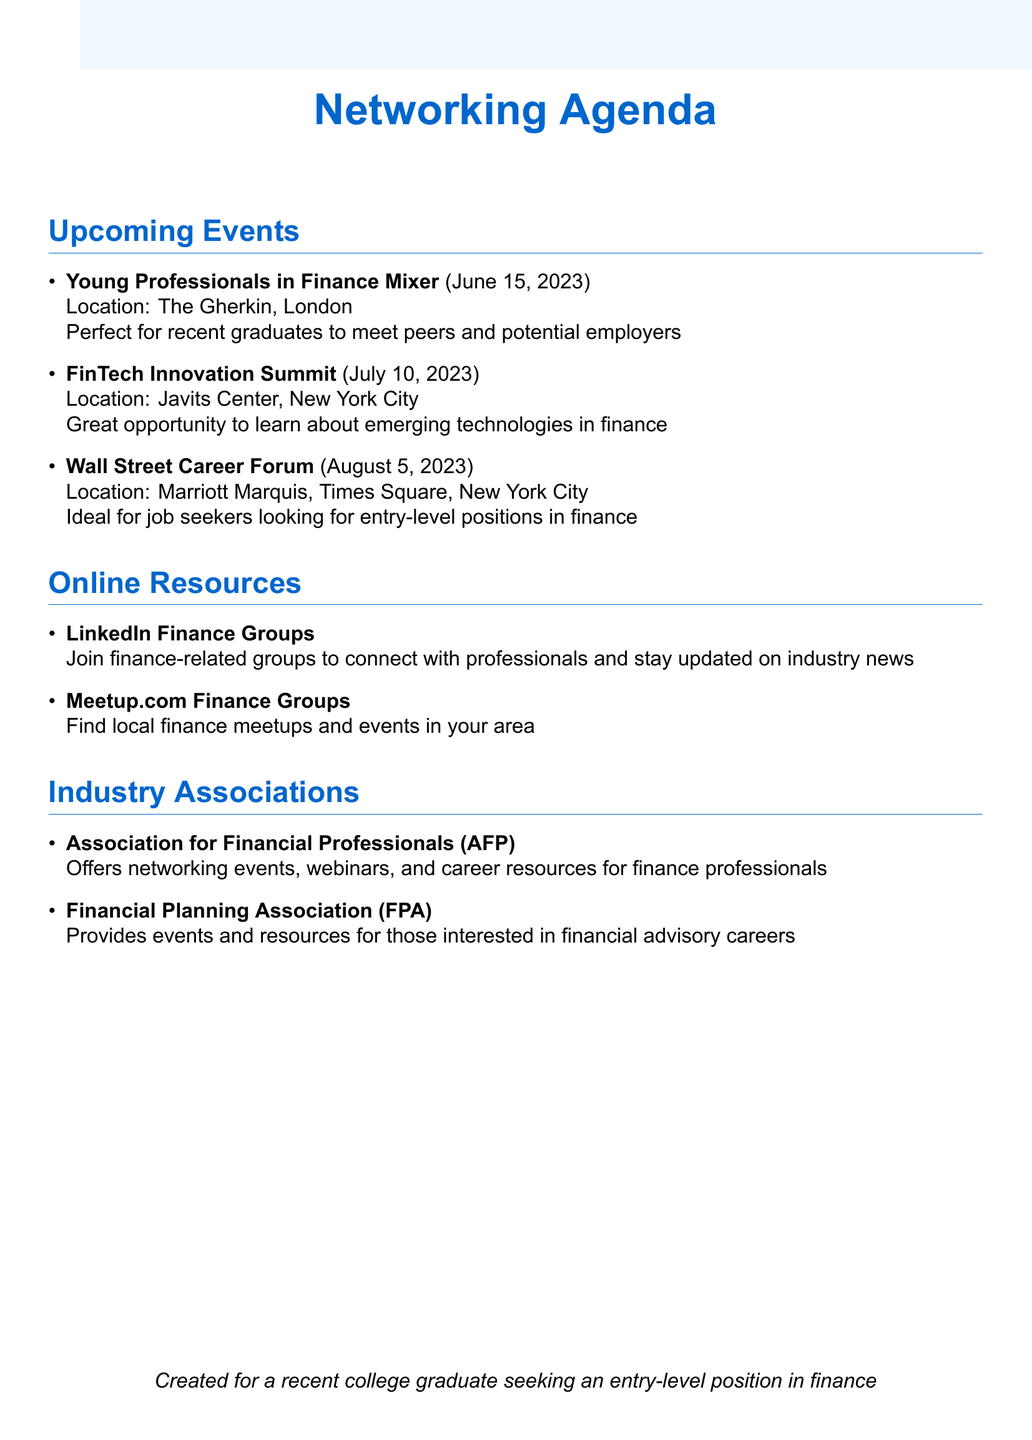What is the date of the Young Professionals in Finance Mixer? The document lists the date of the event as June 15, 2023.
Answer: June 15, 2023 Where is the FinTech Innovation Summit located? The location of the FinTech Innovation Summit is specified in the document as Javits Center, New York City.
Answer: Javits Center, New York City What type of event is the Wall Street Career Forum? The document describes the Wall Street Career Forum as an annual career fair.
Answer: Annual career fair What is the main focus of the Women in Finance Summit? The document states that the Women in Finance Summit focuses on promoting diversity and empowering women in finance.
Answer: Promoting diversity and empowering women How often do local CFA Society Meetups occur? The document mentions that the local CFA Society meetups are monthly.
Answer: Monthly Which online resource is useful for discovering local finance meetups? The document lists Meetup.com Finance Groups as a resource for local finance meetups.
Answer: Meetup.com Finance Groups What does the Association for Financial Professionals offer? The document indicates that the Association for Financial Professionals offers networking events, webinars, and career resources.
Answer: Networking events, webinars, and career resources What is the relevance of the Bloomberg Financial Services Conference? The document states that it provides insights into global finance trends and networking opportunities.
Answer: Insights into global finance trends and networking opportunities 